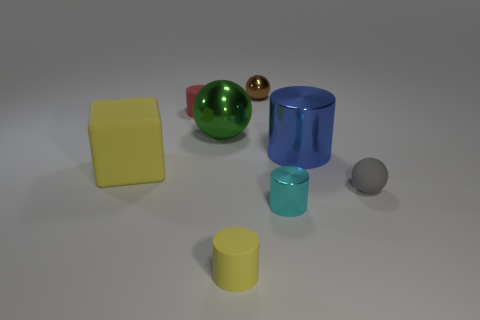Subtract all big cylinders. How many cylinders are left? 3 Subtract all cyan cylinders. How many cylinders are left? 3 Subtract 1 balls. How many balls are left? 2 Add 1 big objects. How many objects exist? 9 Subtract all blocks. How many objects are left? 7 Subtract all yellow cylinders. Subtract all red cubes. How many cylinders are left? 3 Add 5 large shiny spheres. How many large shiny spheres exist? 6 Subtract 0 red balls. How many objects are left? 8 Subtract all balls. Subtract all matte cylinders. How many objects are left? 3 Add 5 gray rubber things. How many gray rubber things are left? 6 